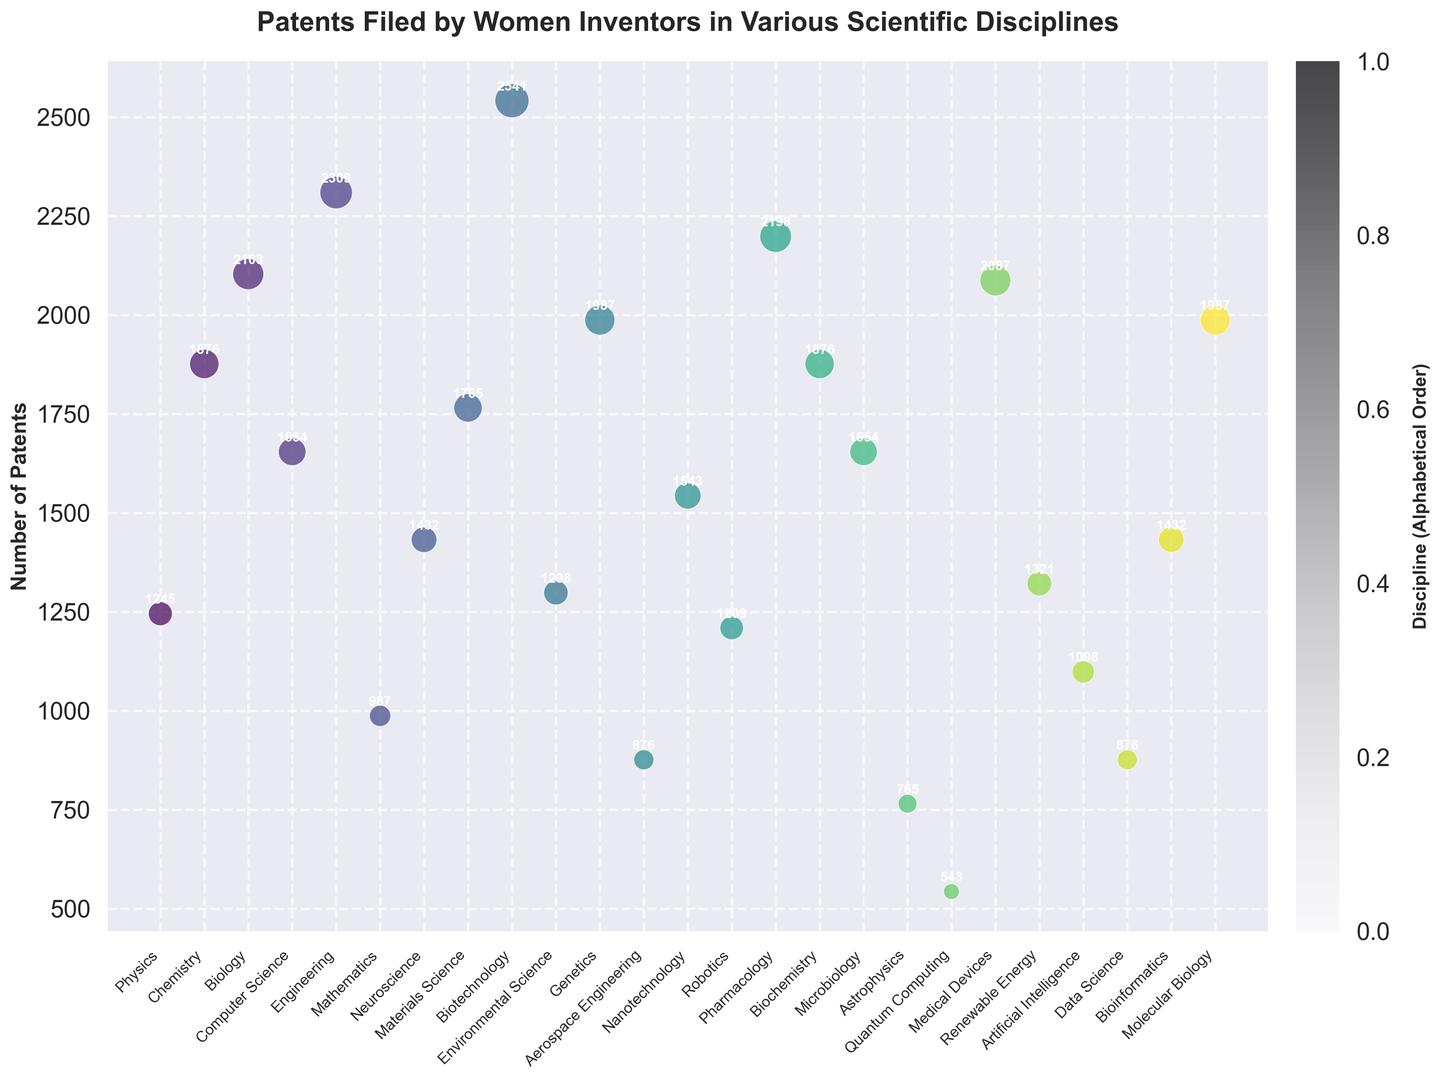What discipline has the most patents filed by women inventors? To determine the discipline with the most patents, we look at the scatter plot and find the highest data point. Biotechnology has 2541 patents, which is the highest value on the chart.
Answer: Biotechnology Which discipline has fewer patents filed than Computer Science? By comparing the number of patents in Computer Science (1654) with others, disciplines like Mathematics (987) and Astrophysics (765) have fewer patents filed.
Answer: Mathematics, Astrophysics What is the total number of patents filed in Biotechnology and Genetics? To find the total, add the number of patents in Biotechnology (2541) and Genetics (1987). 2541 + 1987 = 4528
Answer: 4528 Which disciplines have almost equal numbers of patents filed? Looking at the scatter plot, Chemistry and Biochemistry each have 1876 patents filed.
Answer: Chemistry, Biochemistry What is the average number of patents filed for Astrophysics, Quantum Computing, and Robotics? First, sum the patents filed in Astrophysics (765), Quantum Computing (543), and Robotics (1209). Then, divide by the number of disciplines: (765 + 543 + 1209) / 3 = 2517 / 3 = 839
Answer: 839 Which disciplines have more patents filed than Artificial Intelligence but less than Engineering? Artificial Intelligence has 1098 patents, and Engineering has 2309 patents. Disciplines such as Biology (2103), Biotechnology (2541), and Pharmacology (2198) fall into this range.
Answer: Biology, Pharmacology What is the difference in the number of patents between Environmental Science and Data Science? Subtract the number of patents in Data Science (876) from Environmental Science (1298): 1298 - 876 = 422
Answer: 422 Which discipline has the smallest number of patents filed, and how many? By inspecting the scatter plot, Quantum Computing has the smallest number of patents filed with 543 patents.
Answer: Quantum Computing, 543 What color represents the discipline with the least number of patents? Quantum Computing has the least number of patents (543), and it is represented by a light color towards one end of the color gradient.
Answer: Light color (end of gradient) Which discipline falls nearly in the middle of the patents distribution? By visually estimating, Neuroscience with 1432 patents appears to be near the median of the dataset.
Answer: Neuroscience 